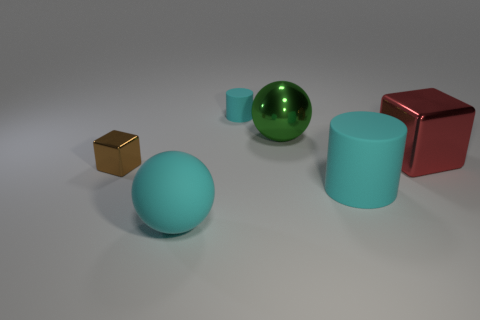What number of rubber objects are either cyan cylinders or big brown spheres?
Provide a short and direct response. 2. Is the matte ball the same color as the large matte cylinder?
Provide a short and direct response. Yes. Are there any other things that have the same color as the small matte cylinder?
Keep it short and to the point. Yes. Does the cyan thing that is on the right side of the small cyan rubber cylinder have the same shape as the tiny object on the left side of the small cyan thing?
Provide a succinct answer. No. How many objects are either red shiny objects or cyan rubber things in front of the big red block?
Provide a succinct answer. 3. What number of other things are there of the same size as the brown object?
Keep it short and to the point. 1. Does the block left of the green thing have the same material as the large ball left of the green sphere?
Your answer should be compact. No. There is a tiny metallic block; what number of big rubber cylinders are in front of it?
Your response must be concise. 1. How many gray things are either large balls or small metal spheres?
Your answer should be compact. 0. What is the material of the cyan cylinder that is the same size as the brown metal cube?
Your answer should be compact. Rubber. 